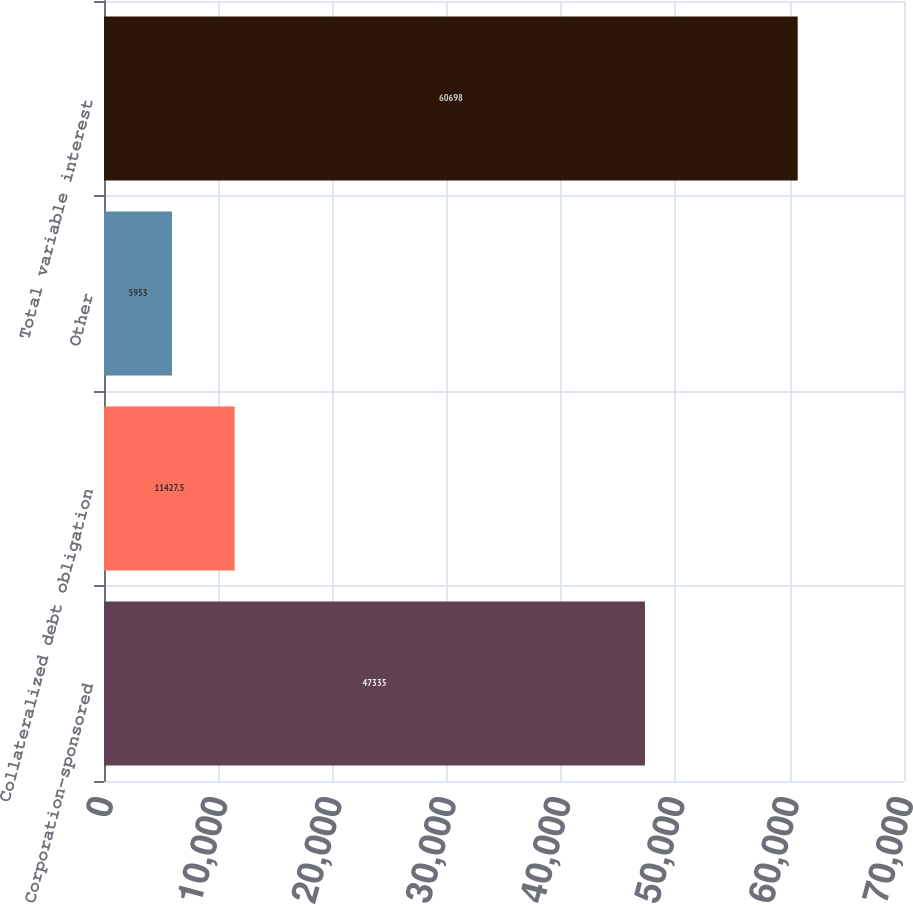Convert chart. <chart><loc_0><loc_0><loc_500><loc_500><bar_chart><fcel>Corporation-sponsored<fcel>Collateralized debt obligation<fcel>Other<fcel>Total variable interest<nl><fcel>47335<fcel>11427.5<fcel>5953<fcel>60698<nl></chart> 